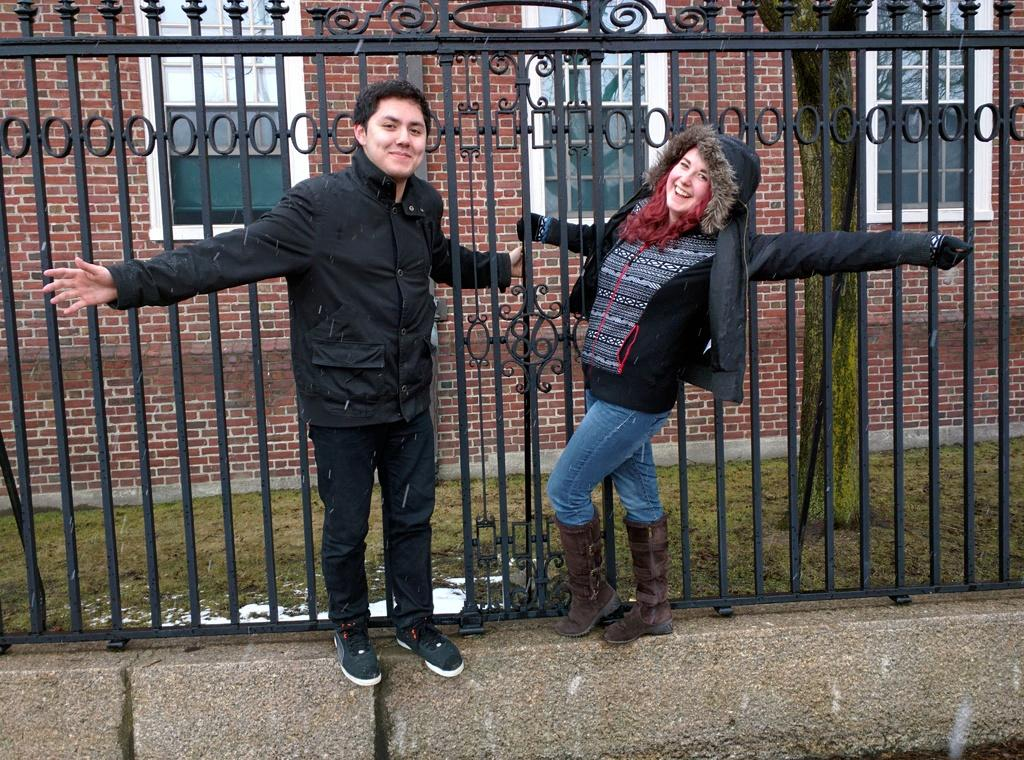What type of structure can be seen in the background of the image? There is a brick wall in the background of the image. What architectural features are visible in the background? There are windows in the background of the image. Who is present in the image? There is a man and a woman in the image. What are the man and woman doing in the image? The man and woman are giving a pose and standing. What is the emotional expression of the man and woman in the image? The man and woman are smiling in the image. What type of hospital can be seen in the image? There is no hospital present in the image. What topic are the man and woman discussing in the image? The image does not show the man and woman talking or discussing any specific topic. 